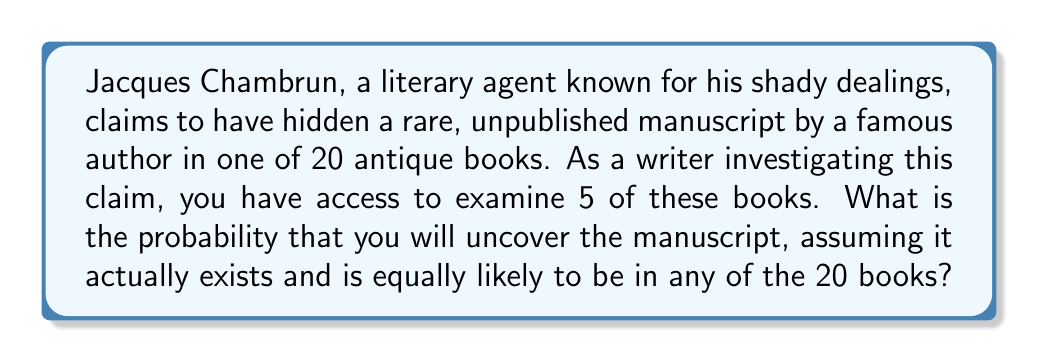Can you solve this math problem? To solve this problem, we can use the concept of combinatorics, specifically the combination formula.

1) First, let's consider the total number of ways to choose 5 books out of 20. This is given by the combination formula:

   $$\binom{20}{5} = \frac{20!}{5!(20-5)!} = \frac{20!}{5!15!}$$

2) Now, for the probability to be successful, the manuscript must be in one of the 5 books we choose. This is equivalent to choosing the book with the manuscript (1 way) and then choosing 4 more books from the remaining 19.

   $$1 \cdot \binom{19}{4} = 1 \cdot \frac{19!}{4!15!}$$

3) The probability is then the number of favorable outcomes divided by the total number of possible outcomes:

   $$P(\text{finding manuscript}) = \frac{1 \cdot \binom{19}{4}}{\binom{20}{5}}$$

4) Let's calculate this:

   $$P(\text{finding manuscript}) = \frac{1 \cdot \frac{19!}{4!15!}}{\frac{20!}{5!15!}}$$

5) The 15! cancels out in the numerator and denominator:

   $$P(\text{finding manuscript}) = \frac{1 \cdot \frac{19!}{4!}}{\frac{20!}{5!}}$$

6) Simplify:

   $$P(\text{finding manuscript}) = \frac{19! \cdot 5!}{4! \cdot 20!} = \frac{19 \cdot 5}{20 \cdot 20} = \frac{95}{400} = \frac{19}{80}$$

Therefore, the probability of finding the manuscript is $\frac{19}{80}$ or 0.2375 or 23.75%.
Answer: $\frac{19}{80}$ or 0.2375 or 23.75% 